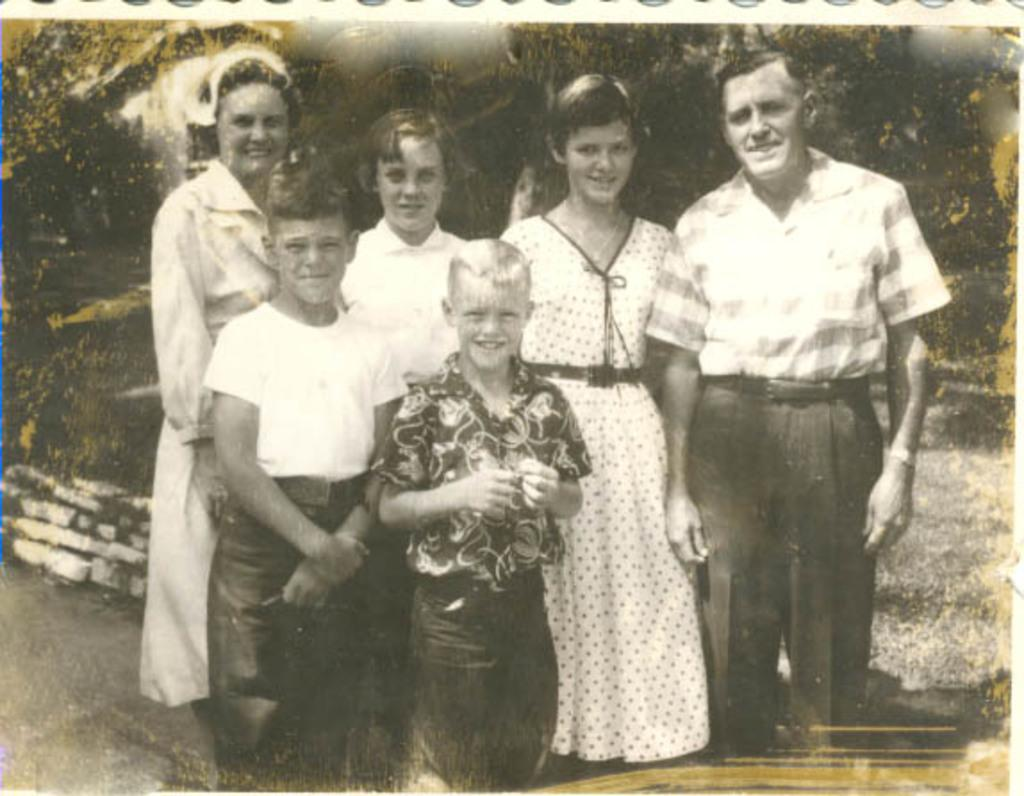How many persons are visible in the image? There are persons standing in the image. What is the facial expression of the persons in the image? The persons are smiling. What can be seen in the background of the image? There are trees and walls in the background of the image. What is the condition of the ground in the image? Dry grass is present on the ground. How many fingers can be seen on the persons' toes in the image? There are no fingers or toes visible on the persons in the image. What type of nail is being used by the persons in the image? There is no nail being used by the persons in the image. 